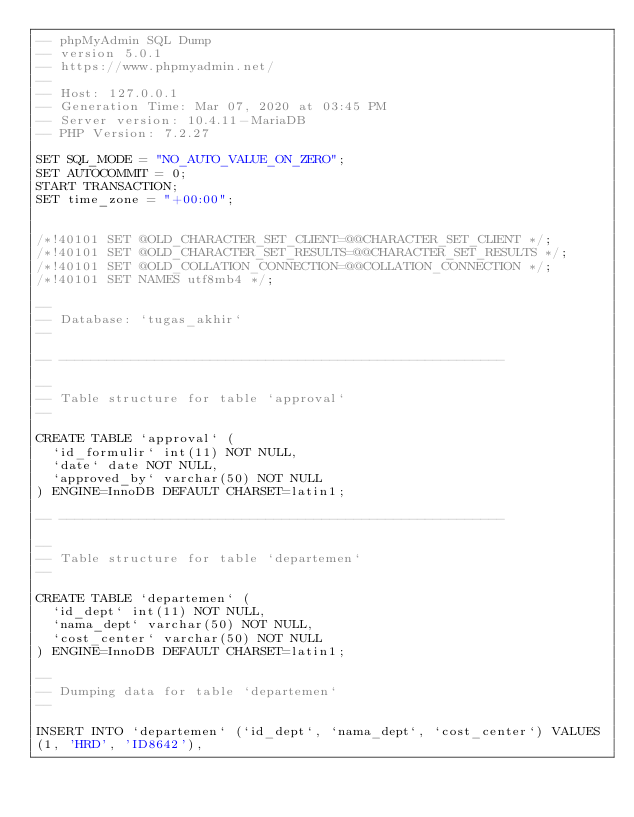Convert code to text. <code><loc_0><loc_0><loc_500><loc_500><_SQL_>-- phpMyAdmin SQL Dump
-- version 5.0.1
-- https://www.phpmyadmin.net/
--
-- Host: 127.0.0.1
-- Generation Time: Mar 07, 2020 at 03:45 PM
-- Server version: 10.4.11-MariaDB
-- PHP Version: 7.2.27

SET SQL_MODE = "NO_AUTO_VALUE_ON_ZERO";
SET AUTOCOMMIT = 0;
START TRANSACTION;
SET time_zone = "+00:00";


/*!40101 SET @OLD_CHARACTER_SET_CLIENT=@@CHARACTER_SET_CLIENT */;
/*!40101 SET @OLD_CHARACTER_SET_RESULTS=@@CHARACTER_SET_RESULTS */;
/*!40101 SET @OLD_COLLATION_CONNECTION=@@COLLATION_CONNECTION */;
/*!40101 SET NAMES utf8mb4 */;

--
-- Database: `tugas_akhir`
--

-- --------------------------------------------------------

--
-- Table structure for table `approval`
--

CREATE TABLE `approval` (
  `id_formulir` int(11) NOT NULL,
  `date` date NOT NULL,
  `approved_by` varchar(50) NOT NULL
) ENGINE=InnoDB DEFAULT CHARSET=latin1;

-- --------------------------------------------------------

--
-- Table structure for table `departemen`
--

CREATE TABLE `departemen` (
  `id_dept` int(11) NOT NULL,
  `nama_dept` varchar(50) NOT NULL,
  `cost_center` varchar(50) NOT NULL
) ENGINE=InnoDB DEFAULT CHARSET=latin1;

--
-- Dumping data for table `departemen`
--

INSERT INTO `departemen` (`id_dept`, `nama_dept`, `cost_center`) VALUES
(1, 'HRD', 'ID8642'),</code> 